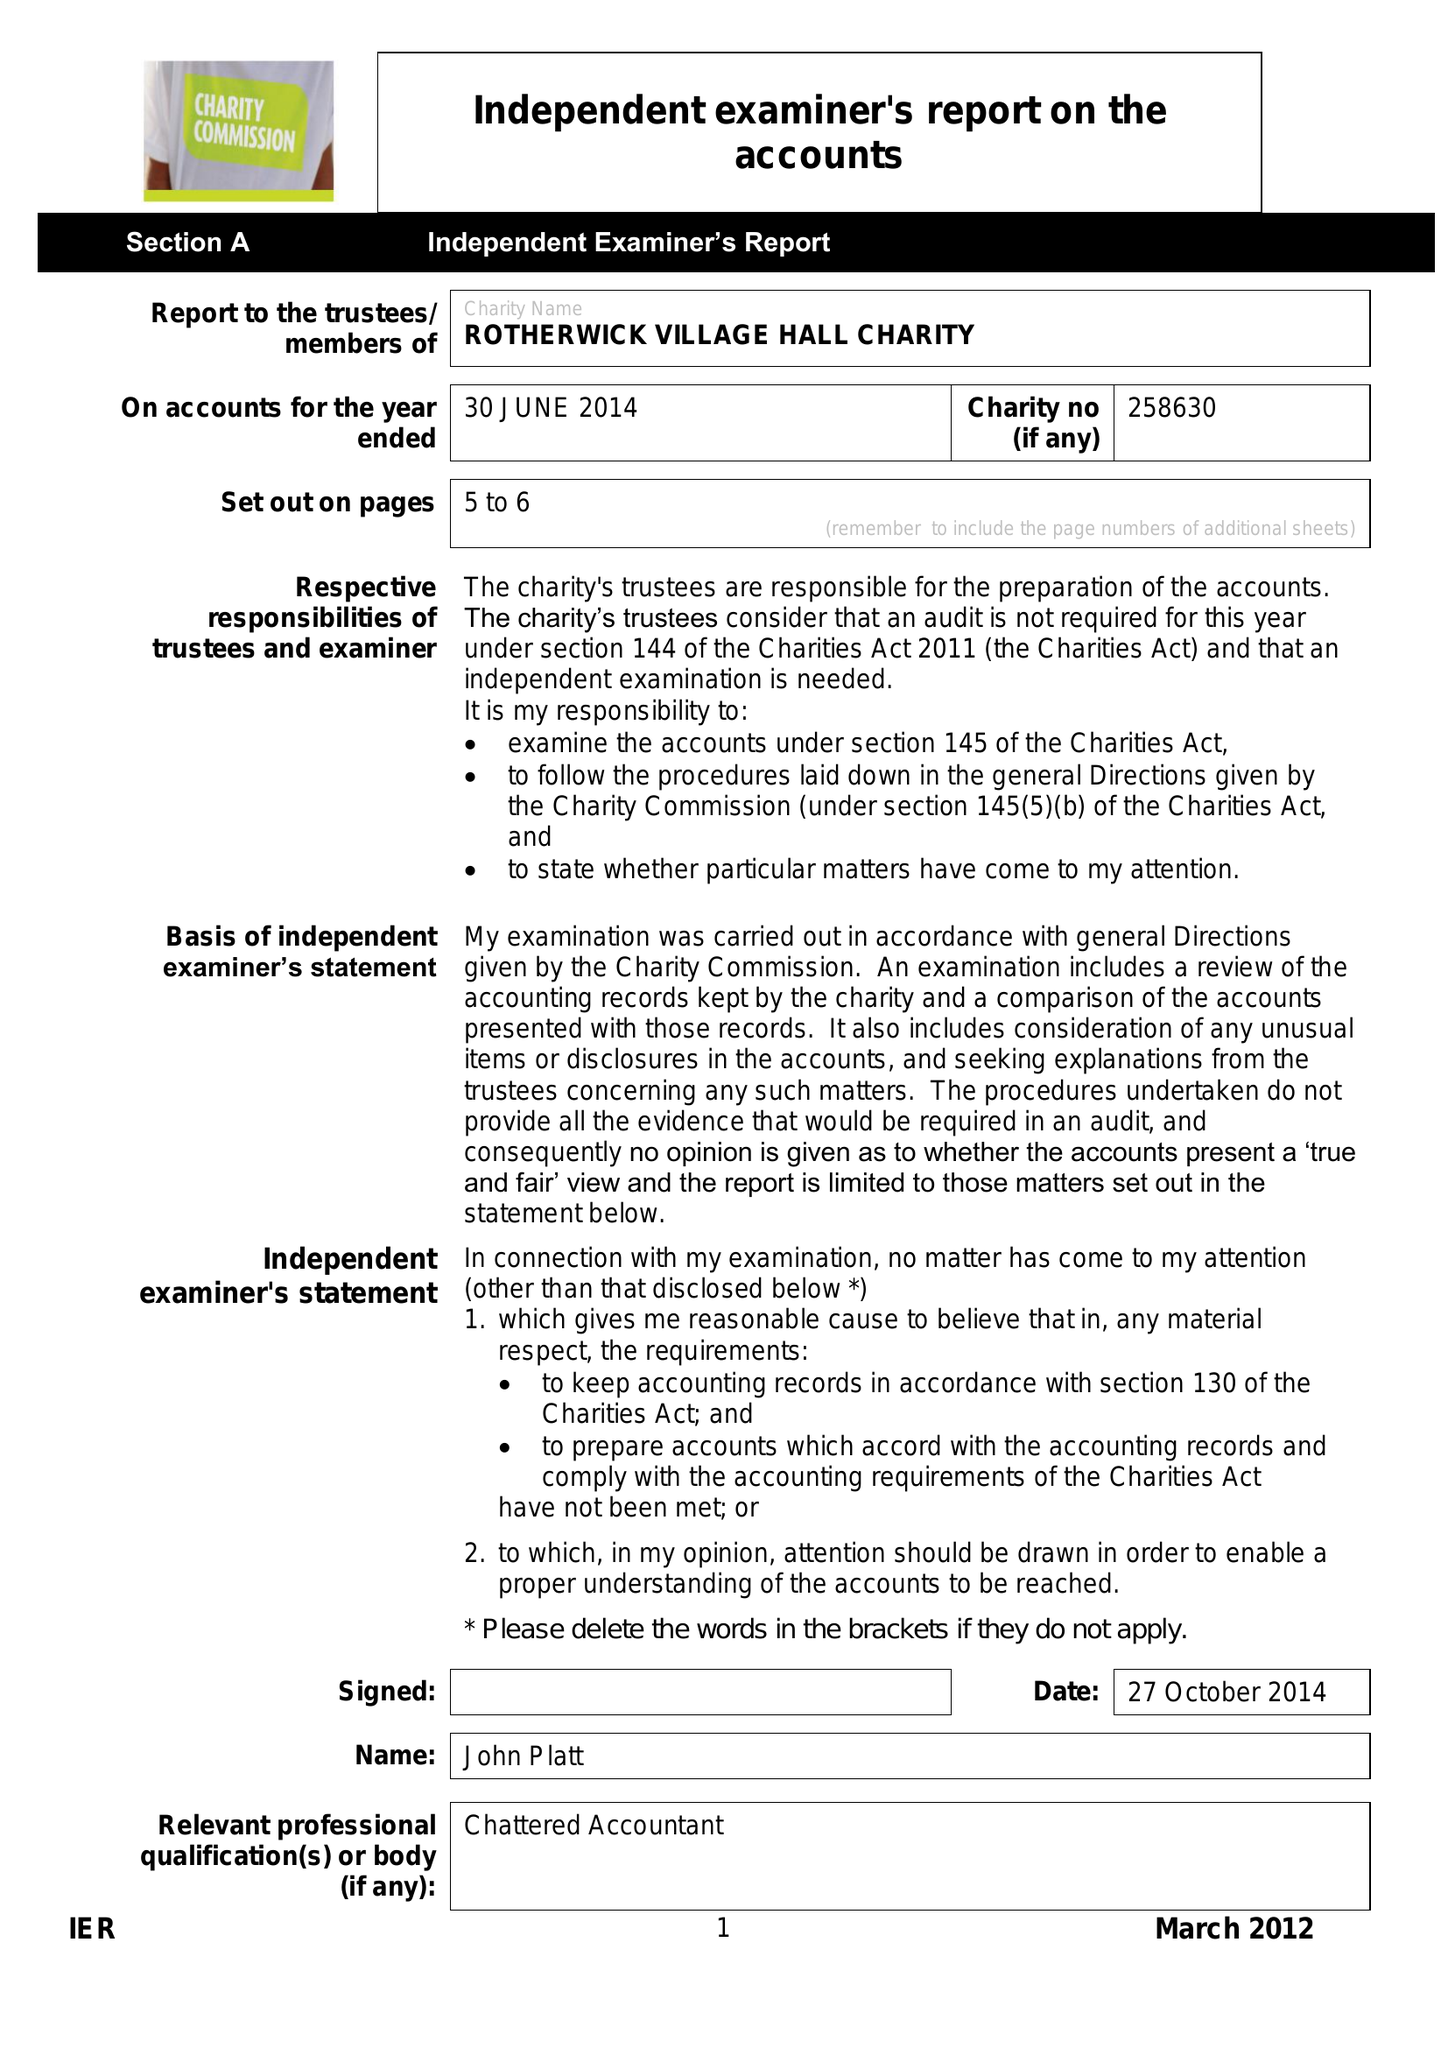What is the value for the address__street_line?
Answer the question using a single word or phrase. THE STREET 